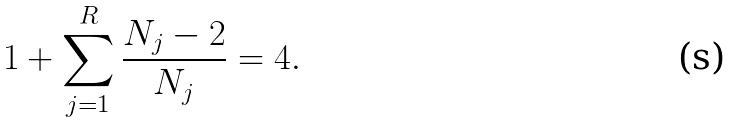Convert formula to latex. <formula><loc_0><loc_0><loc_500><loc_500>1 + \sum _ { j = 1 } ^ { R } \frac { N _ { j } - 2 } { N _ { j } } = 4 .</formula> 